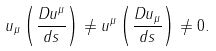Convert formula to latex. <formula><loc_0><loc_0><loc_500><loc_500>u _ { \mu } \left ( \frac { D u ^ { \mu } } { d s } \right ) \neq u ^ { \mu } \left ( \frac { D u _ { \mu } } { d s } \right ) \neq 0 .</formula> 